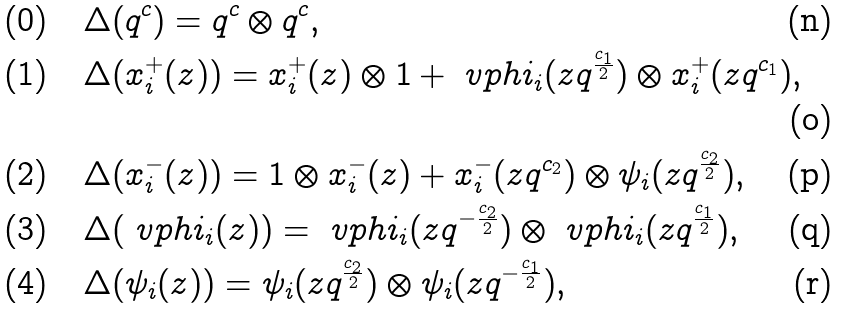<formula> <loc_0><loc_0><loc_500><loc_500>\text {(0)} & \quad \Delta ( q ^ { c } ) = q ^ { c } \otimes q ^ { c } , \\ \text {(1)} & \quad \Delta ( x _ { i } ^ { + } ( z ) ) = x _ { i } ^ { + } ( z ) \otimes 1 + \ v p h i _ { i } ( z q ^ { \frac { c _ { 1 } } { 2 } } ) \otimes x _ { i } ^ { + } ( z q ^ { c _ { 1 } } ) , \\ \text {(2)} & \quad \Delta ( x _ { i } ^ { - } ( z ) ) = 1 \otimes x _ { i } ^ { - } ( z ) + x _ { i } ^ { - } ( z q ^ { c _ { 2 } } ) \otimes \psi _ { i } ( z q ^ { \frac { c _ { 2 } } { 2 } } ) , \\ \text {(3)} & \quad \Delta ( \ v p h i _ { i } ( z ) ) = \ v p h i _ { i } ( z q ^ { - \frac { c _ { 2 } } { 2 } } ) \otimes \ v p h i _ { i } ( z q ^ { \frac { c _ { 1 } } { 2 } } ) , \\ \text {(4)} & \quad \Delta ( \psi _ { i } ( z ) ) = \psi _ { i } ( z q ^ { \frac { c _ { 2 } } { 2 } } ) \otimes \psi _ { i } ( z q ^ { - \frac { c _ { 1 } } { 2 } } ) ,</formula> 